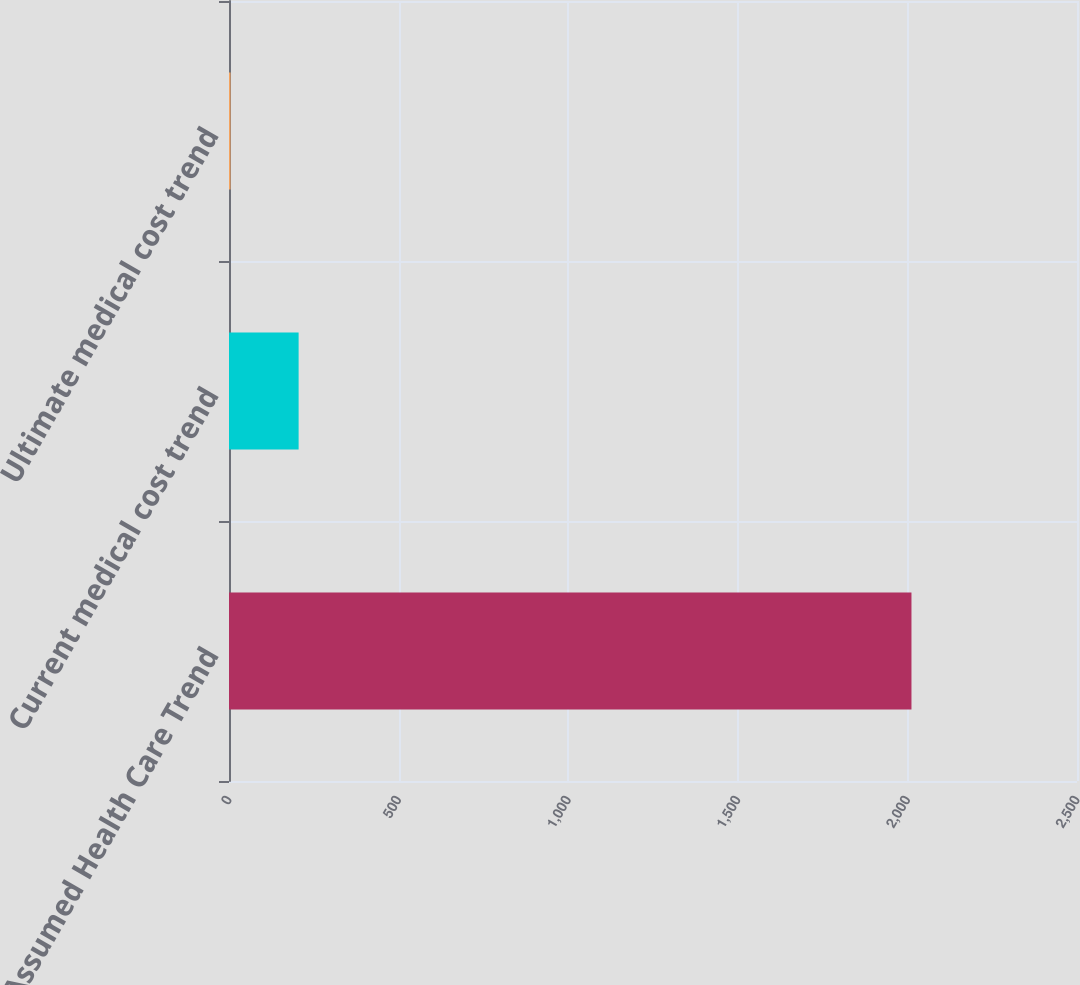Convert chart to OTSL. <chart><loc_0><loc_0><loc_500><loc_500><bar_chart><fcel>Assumed Health Care Trend<fcel>Current medical cost trend<fcel>Ultimate medical cost trend<nl><fcel>2012<fcel>205.25<fcel>4.5<nl></chart> 